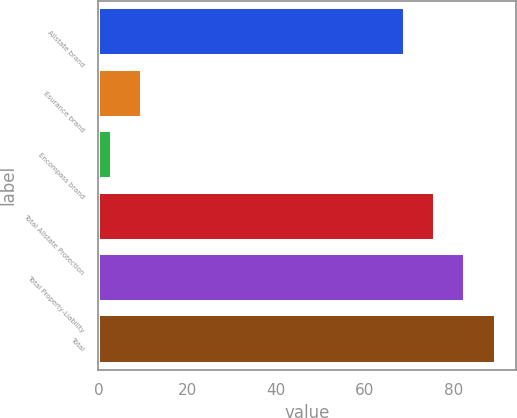Convert chart to OTSL. <chart><loc_0><loc_0><loc_500><loc_500><bar_chart><fcel>Allstate brand<fcel>Esurance brand<fcel>Encompass brand<fcel>Total Allstate Protection<fcel>Total Property-Liability<fcel>Total<nl><fcel>69<fcel>9.8<fcel>3<fcel>75.8<fcel>82.6<fcel>89.4<nl></chart> 